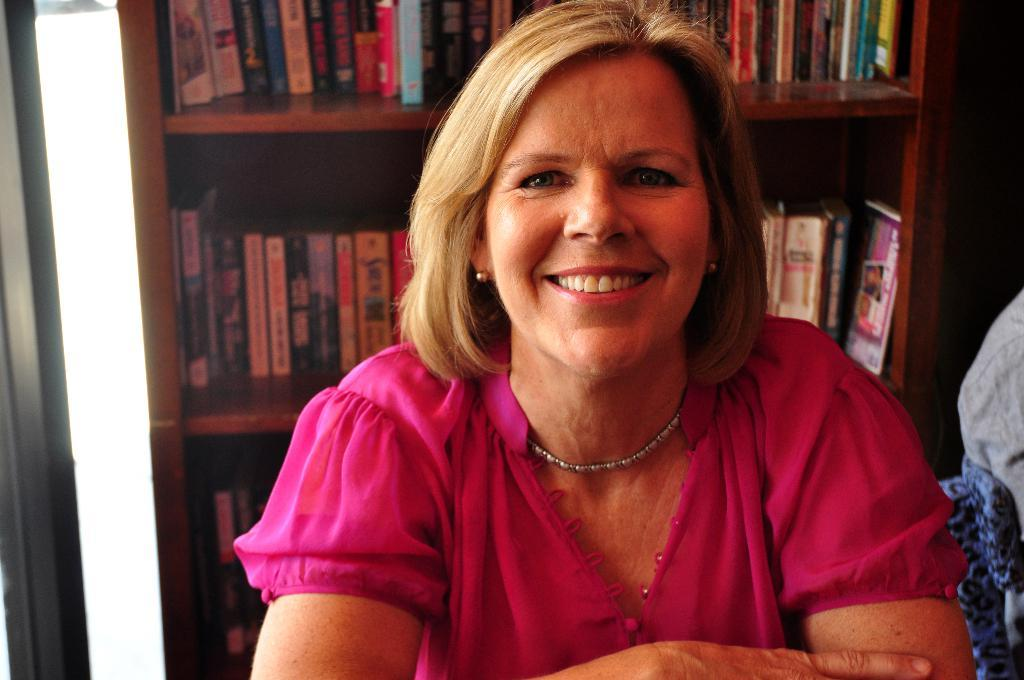Who is the main subject in the image? There is a woman in the image. Where is the woman located in the image? The woman is in the middle of the image. What is the woman wearing? The woman is wearing a pink dress. What expression does the woman have? The woman is smiling. What can be seen in the background of the image? There are books placed on a shelf in the background of the image. What type of coal is being used to heat the stove in the image? There is no stove or coal present in the image; it features a woman wearing a pink dress and smiling. 